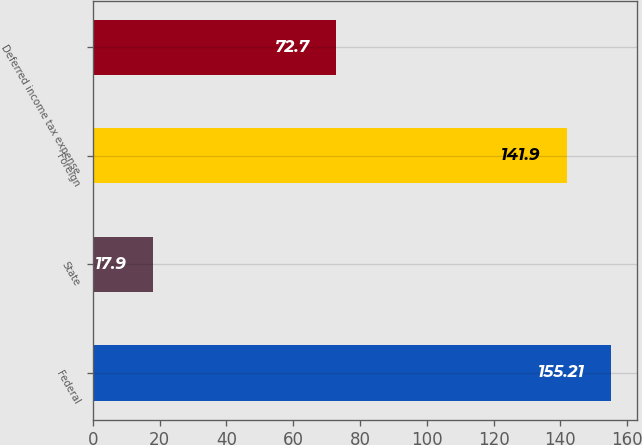Convert chart. <chart><loc_0><loc_0><loc_500><loc_500><bar_chart><fcel>Federal<fcel>State<fcel>Foreign<fcel>Deferred income tax expense<nl><fcel>155.21<fcel>17.9<fcel>141.9<fcel>72.7<nl></chart> 